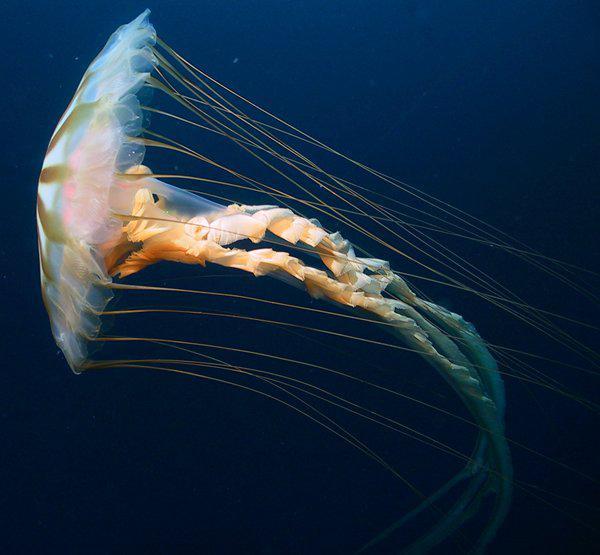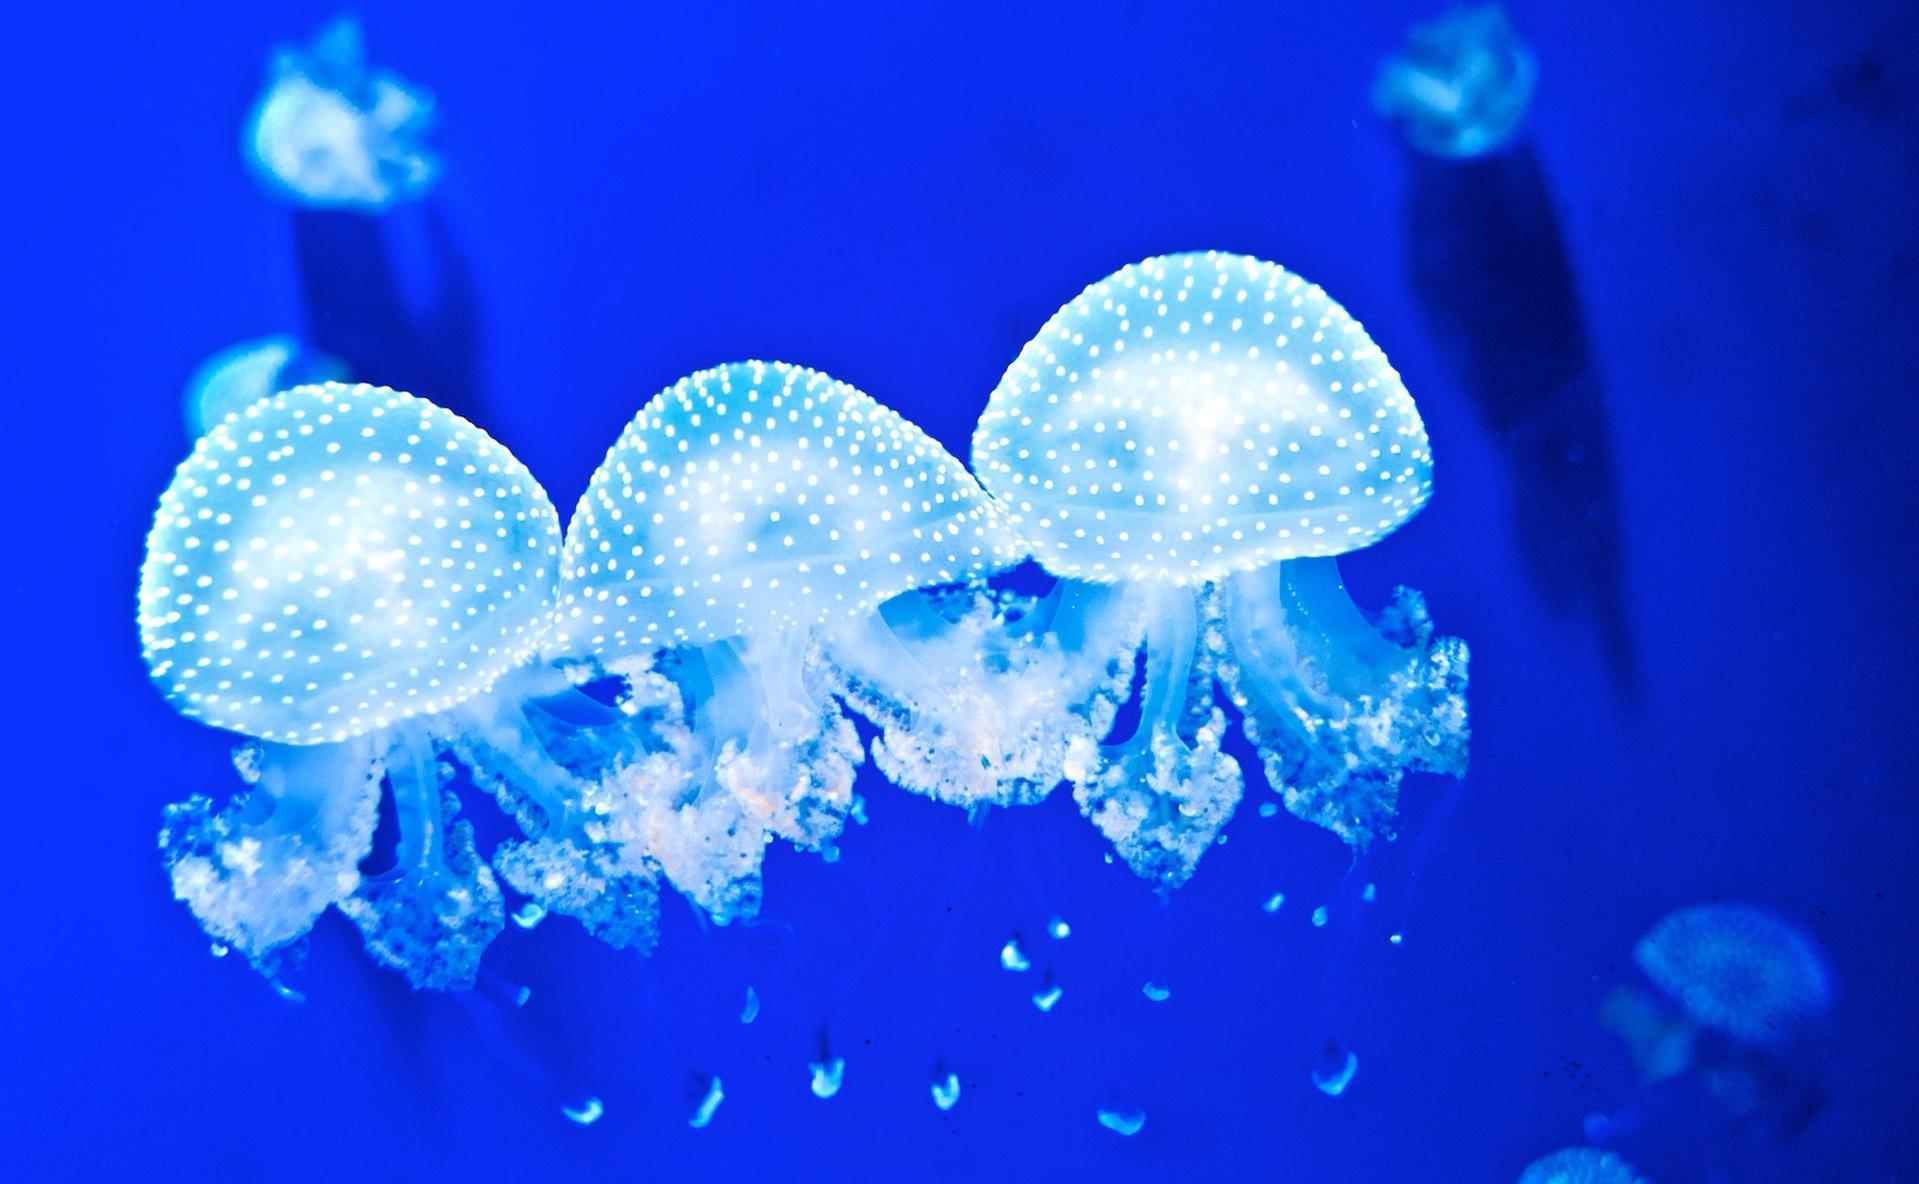The first image is the image on the left, the second image is the image on the right. Given the left and right images, does the statement "In one of the images, a single jellyfish floats on its side" hold true? Answer yes or no. Yes. The first image is the image on the left, the second image is the image on the right. Considering the images on both sides, is "An image shows just one jellyfish, which has long, non-curly tendrils." valid? Answer yes or no. Yes. 